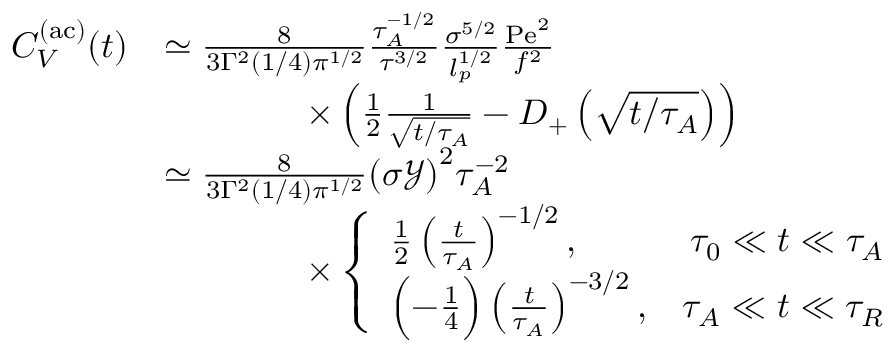<formula> <loc_0><loc_0><loc_500><loc_500>\begin{array} { r l } { C _ { V } ^ { ( a c ) } ( t ) } & { \simeq \frac { 8 } { 3 \Gamma ^ { 2 } ( 1 / 4 ) { \pi } ^ { 1 / 2 } } \frac { \tau _ { A } ^ { - 1 / 2 } } { { \tau } ^ { 3 / 2 } } \frac { \sigma ^ { 5 / 2 } } { l _ { p } ^ { 1 / 2 } } \frac { P e ^ { 2 } } { f ^ { 2 } } } \\ & { \quad \times \left ( \frac { 1 } { 2 } \frac { 1 } { \sqrt { t / \tau _ { A } } } - D _ { + } \left ( \sqrt { t / \tau _ { A } } \right ) \right ) } \\ & { \simeq \frac { 8 } { 3 \Gamma ^ { 2 } ( 1 / 4 ) { \pi } ^ { 1 / 2 } } { ( \sigma \mathcal { Y } ) } ^ { 2 } \tau _ { A } ^ { - 2 } } \\ & { \quad \times \left \{ \begin{array} { l r } { \frac { 1 } { 2 } \left ( \frac { t } { \tau _ { A } } \right ) ^ { - 1 / 2 } , } & { \tau _ { 0 } \ll t \ll \tau _ { A } } \\ { \left ( - \frac { 1 } { 4 } \right ) \left ( \frac { t } { \tau _ { A } } \right ) ^ { - 3 / 2 } , } & { \tau _ { A } \ll t \ll \tau _ { R } } \end{array} } \end{array}</formula> 